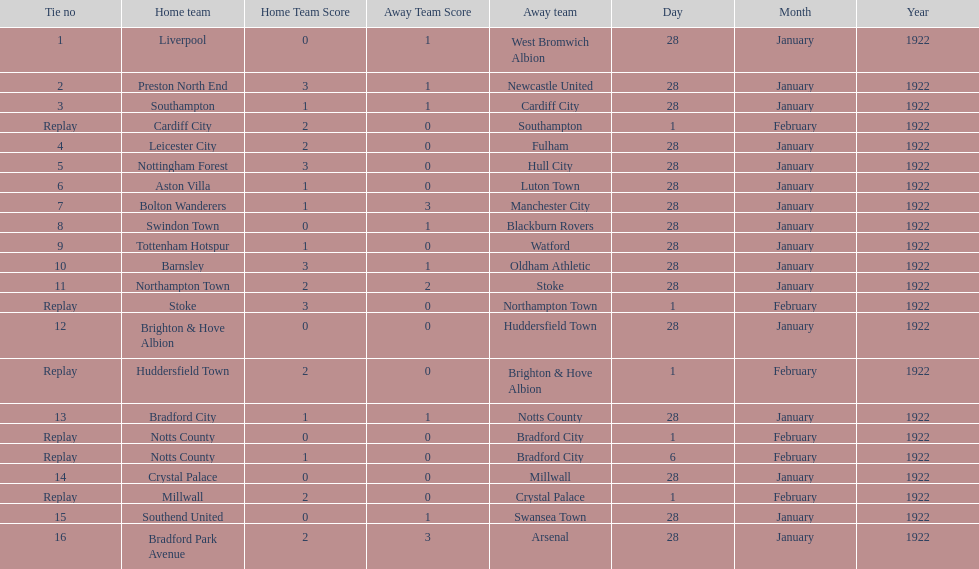How many games had no points scored? 3. 